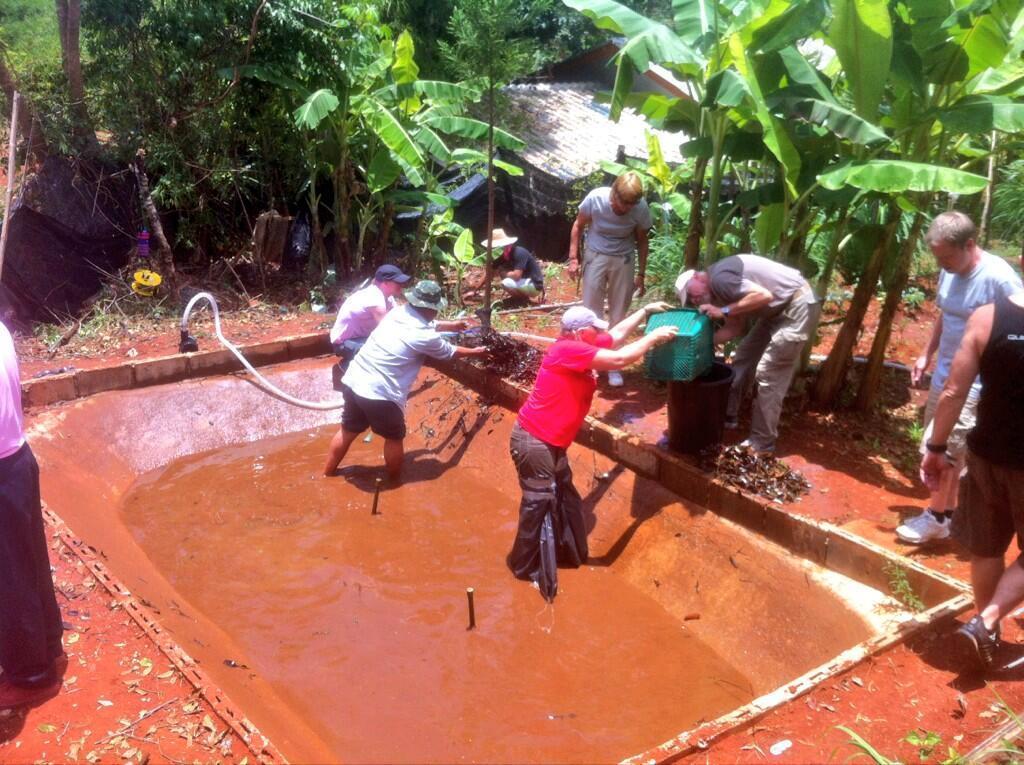Could you give a brief overview of what you see in this image? In the picture we can see some people are standing in the pool of the wet red soil and one man is holding a box and pouring the soil outside and in the background we can see the plants and trees. 